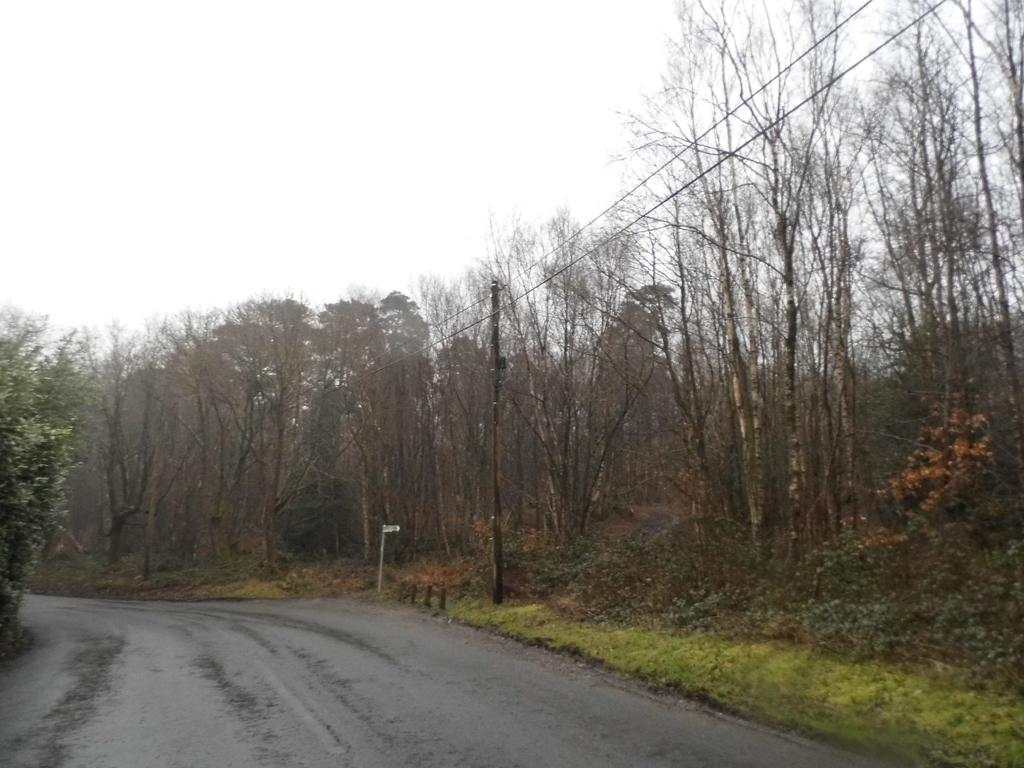What is the main feature of the image? There is a road in the image. What can be seen on either side of the road? There are trees on either side of the road. Is there any other structure or object visible near the road? Yes, there is a pole on the right side of the road. What type of crown can be seen on the pole in the image? There is no crown present on the pole or anywhere else in the image. 